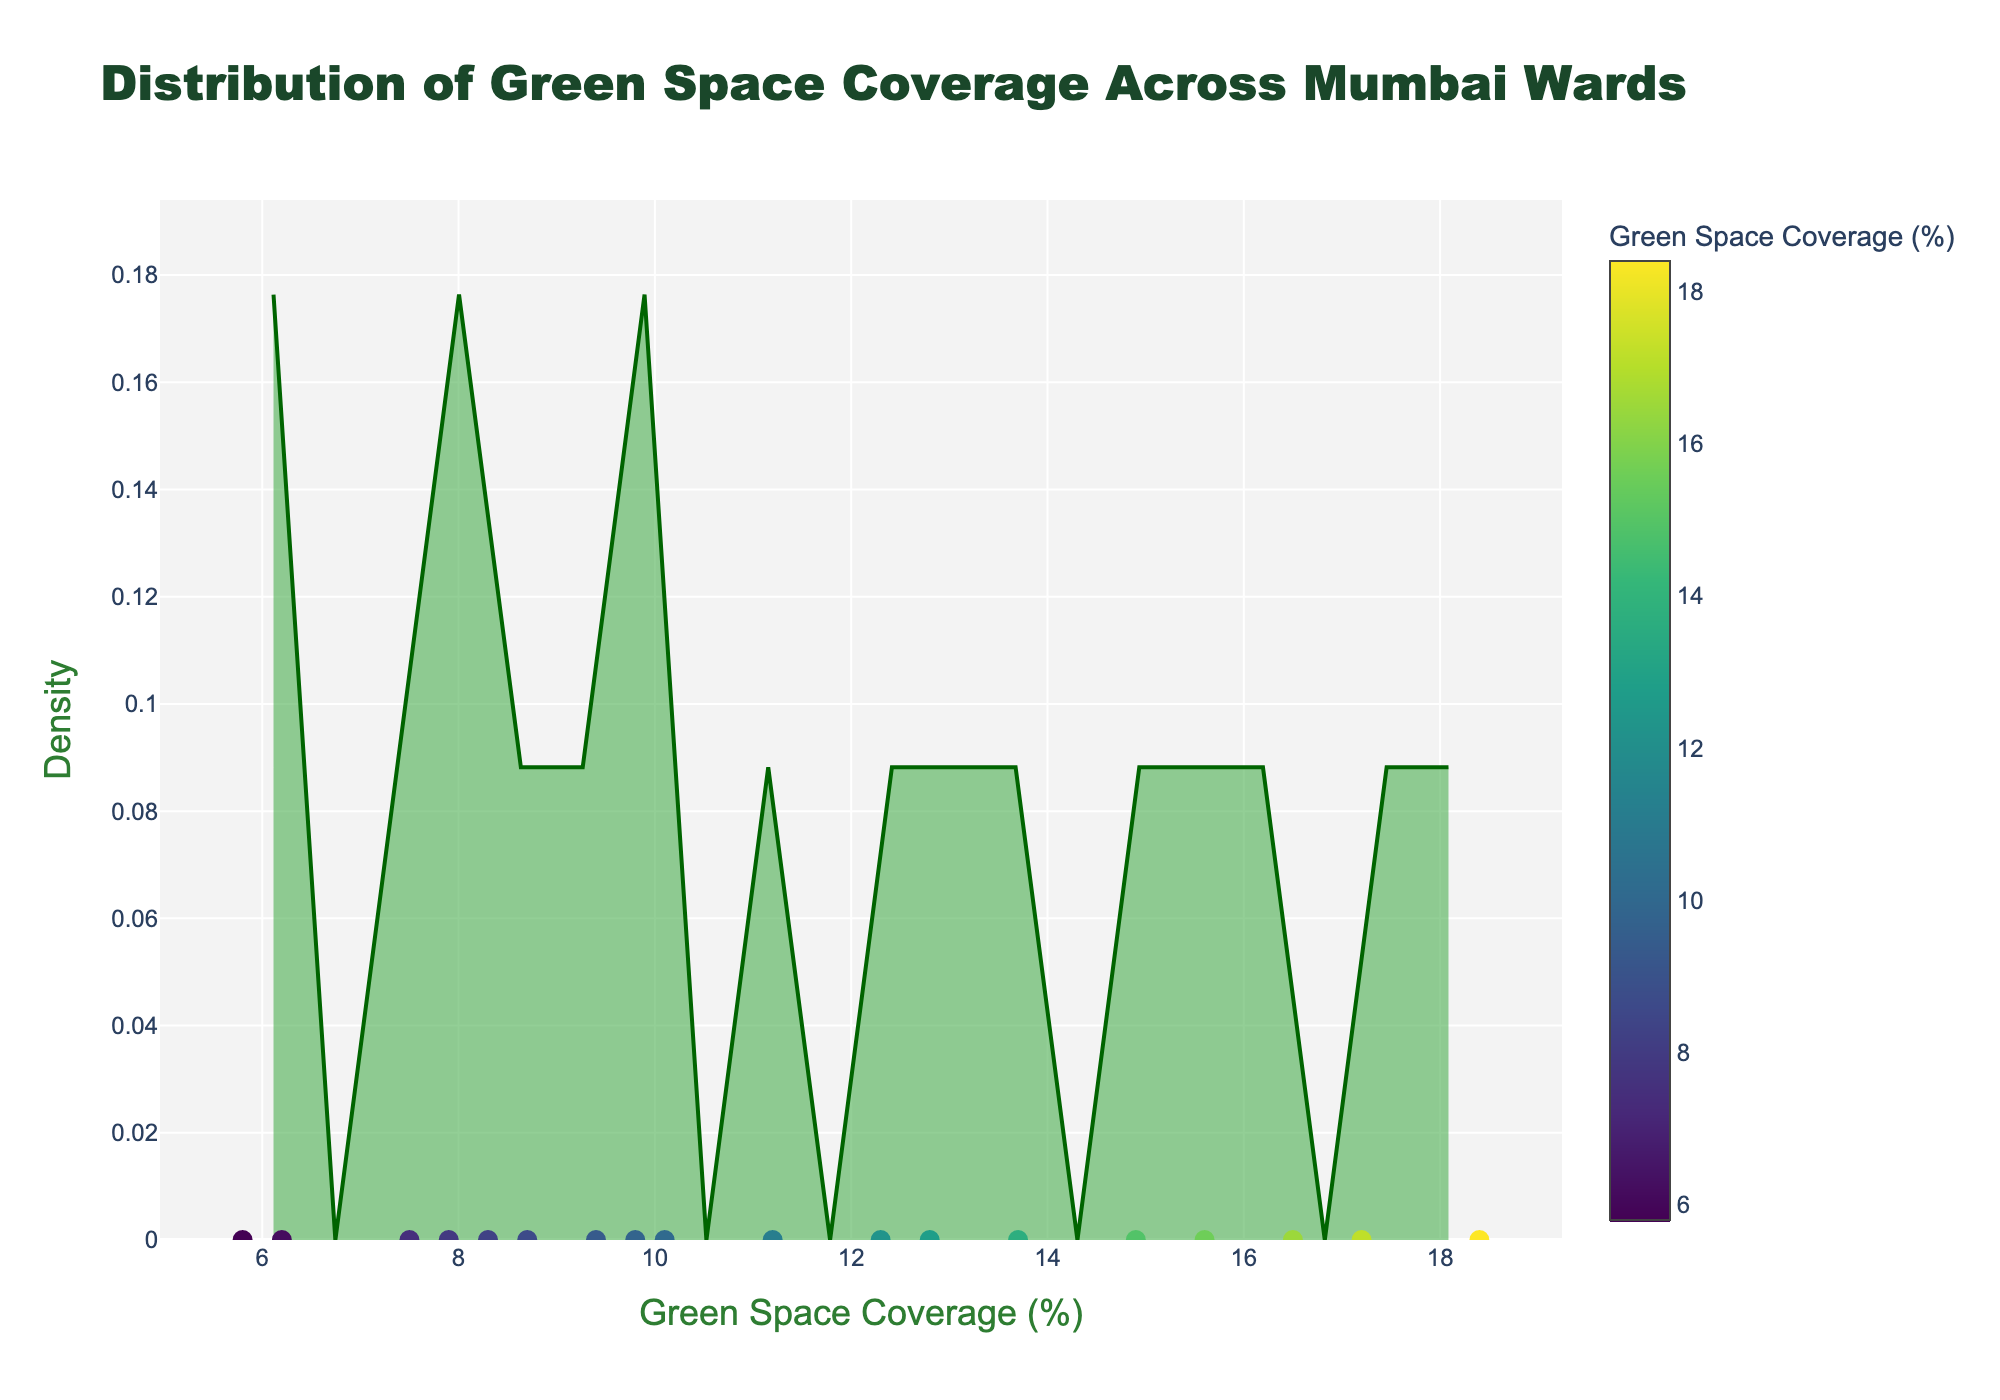What is the title of the plot? The title is usually displayed prominently at the top of the figure. For this plot, it reads "Distribution of Green Space Coverage Across Mumbai Wards."
Answer: Distribution of Green Space Coverage Across Mumbai Wards What does the x-axis represent on the plot? The x-axis title is mentioned explicitly in the plot and it reads "Green Space Coverage (%)." This means the x-axis represents the percentage of green space coverage.
Answer: Green Space Coverage (%) How many wards have their green space coverage marked on the plot? The plot includes markers for each ward’s green space coverage percentage. Since every ward’s percentage is displayed, we count the number of wards in the dataset (18) or observe the markers on the x-axis.
Answer: 18 Which ward has the highest green space coverage percentage? By checking the markers on the x-axis and noting their corresponding values, we see that ward F/N has the highest coverage percentage at 18.4%.
Answer: F/N What is the range of green space coverage percentages across Mumbai’s wards? The lowest value in the dataset is 5.8% (ward L), and the highest is 18.4% (ward F/N), so the range is 18.4% - 5.8% = 12.6%.
Answer: 12.6% Which ward has the lowest green space coverage percentage? Similar to finding the highest, we check the markers on the x-axis and find the lowest value, which corresponds to ward L with 5.8%.
Answer: L What is the median green space coverage percentage of the wards? To find the median, the green space percentages need to be ordered: [5.8, 6.2, 7.5, 7.9, 8.3, 8.7, 9.4, 9.8, 10.1, 11.2, 12.3, 12.8, 13.7, 14.9, 15.6, 16.5, 17.2, 18.4]. The median is the middle value for odd numbers or the average of the two middle values for an even set. Here, the middle values are 10.1 and 11.2, so (10.1 + 11.2) / 2 = 10.65%.
Answer: 10.65% Which wards have green space coverage greater than 15%? By filtering the wards with values over 15% from the plot or dataset, we find wards C (15.6%), R/C (16.5%), T (17.2%), and F/N (18.4%).
Answer: C, R/C, T, F/N What is the average green space coverage percentage? Adding all percentages and dividing by the number of wards: (12.3+8.7+15.6+6.2+9.8+18.4+7.5+11.2+14.9+5.8+10.1+13.7+8.3+16.5+7.9+12.8+9.4+17.2) / 18 = 11.4%.
Answer: 11.4% What does the height of the density curve represent? The y-axis is labeled 'Density,' indicating that the curve's height represents the density of wards with green space coverage in that range, normalized to form a probability density function.
Answer: Density 